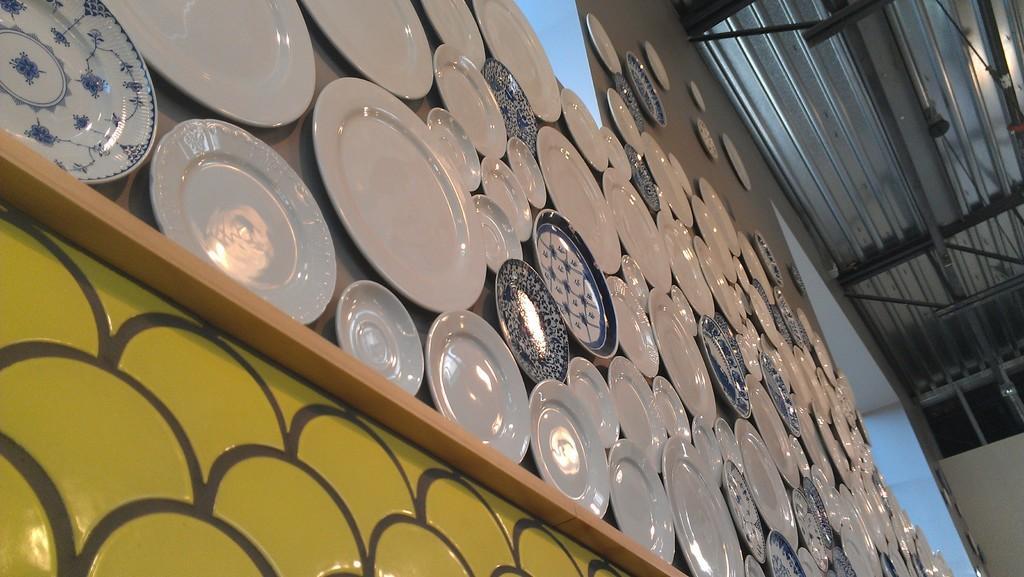In one or two sentences, can you explain what this image depicts? In this image I can see number of white and blue colour plates on the wall. 